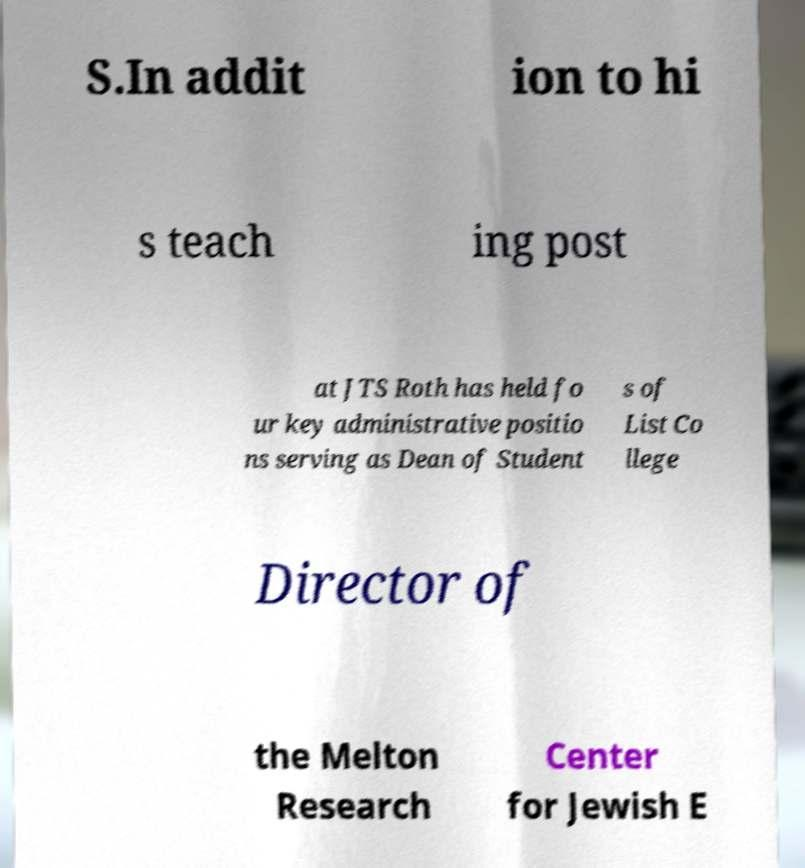Could you assist in decoding the text presented in this image and type it out clearly? S.In addit ion to hi s teach ing post at JTS Roth has held fo ur key administrative positio ns serving as Dean of Student s of List Co llege Director of the Melton Research Center for Jewish E 